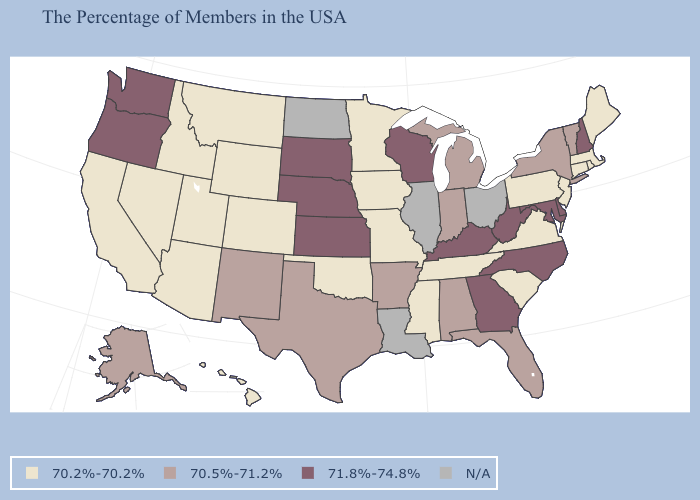What is the highest value in the South ?
Keep it brief. 71.8%-74.8%. Name the states that have a value in the range 71.8%-74.8%?
Keep it brief. New Hampshire, Delaware, Maryland, North Carolina, West Virginia, Georgia, Kentucky, Wisconsin, Kansas, Nebraska, South Dakota, Washington, Oregon. What is the value of South Carolina?
Answer briefly. 70.2%-70.2%. What is the lowest value in the USA?
Give a very brief answer. 70.2%-70.2%. What is the value of Arkansas?
Short answer required. 70.5%-71.2%. Does the map have missing data?
Answer briefly. Yes. How many symbols are there in the legend?
Quick response, please. 4. Name the states that have a value in the range 70.5%-71.2%?
Short answer required. Vermont, New York, Florida, Michigan, Indiana, Alabama, Arkansas, Texas, New Mexico, Alaska. Does Indiana have the highest value in the USA?
Give a very brief answer. No. What is the lowest value in the South?
Concise answer only. 70.2%-70.2%. What is the lowest value in the USA?
Give a very brief answer. 70.2%-70.2%. What is the value of Mississippi?
Concise answer only. 70.2%-70.2%. Among the states that border New York , which have the lowest value?
Concise answer only. Massachusetts, Connecticut, New Jersey, Pennsylvania. What is the lowest value in the West?
Give a very brief answer. 70.2%-70.2%. Among the states that border New Mexico , does Texas have the lowest value?
Short answer required. No. 